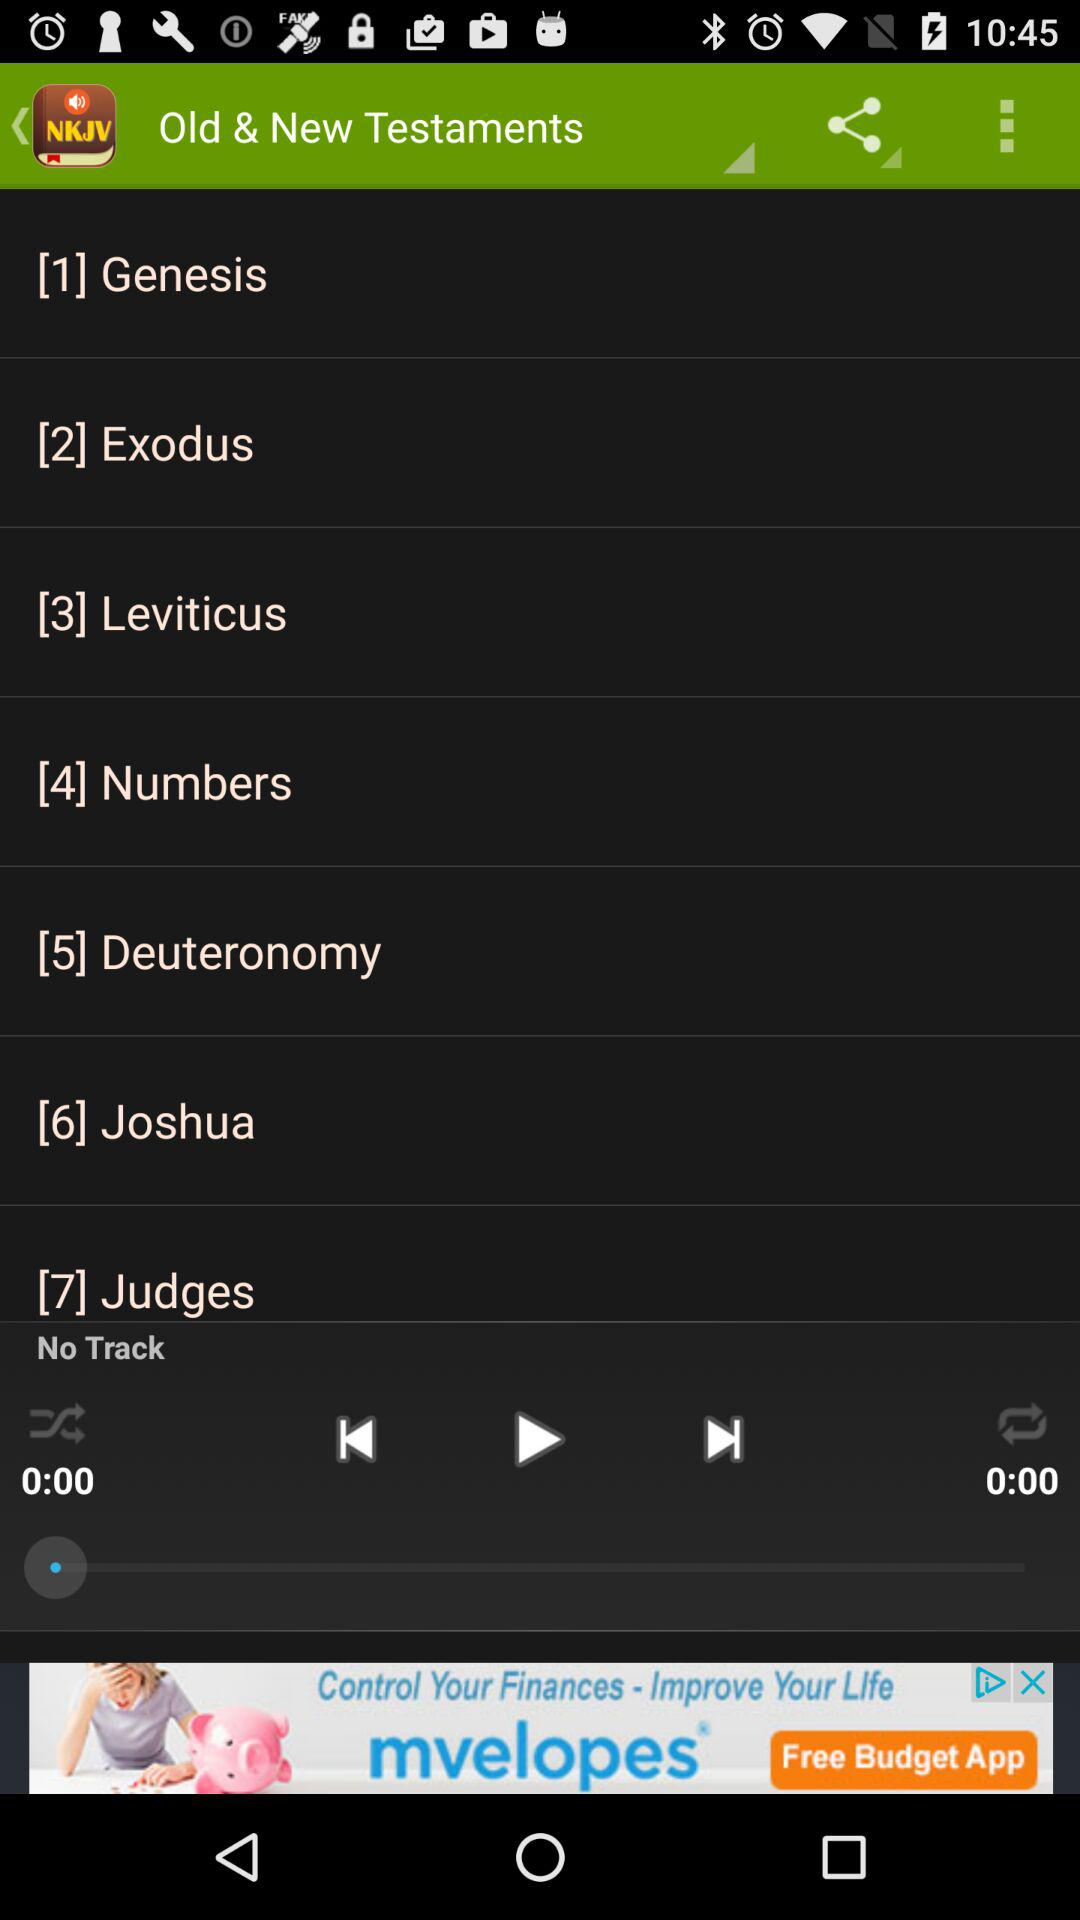What is the total duration? The total duration is 0 minutes. 